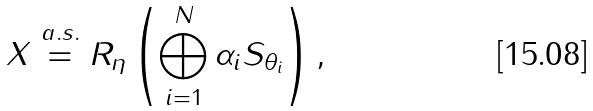<formula> <loc_0><loc_0><loc_500><loc_500>X \stackrel { a . s . } { = } R _ { \eta } \left ( \bigoplus _ { i = 1 } ^ { N } \alpha _ { i } S _ { \theta _ { i } } \right ) ,</formula> 